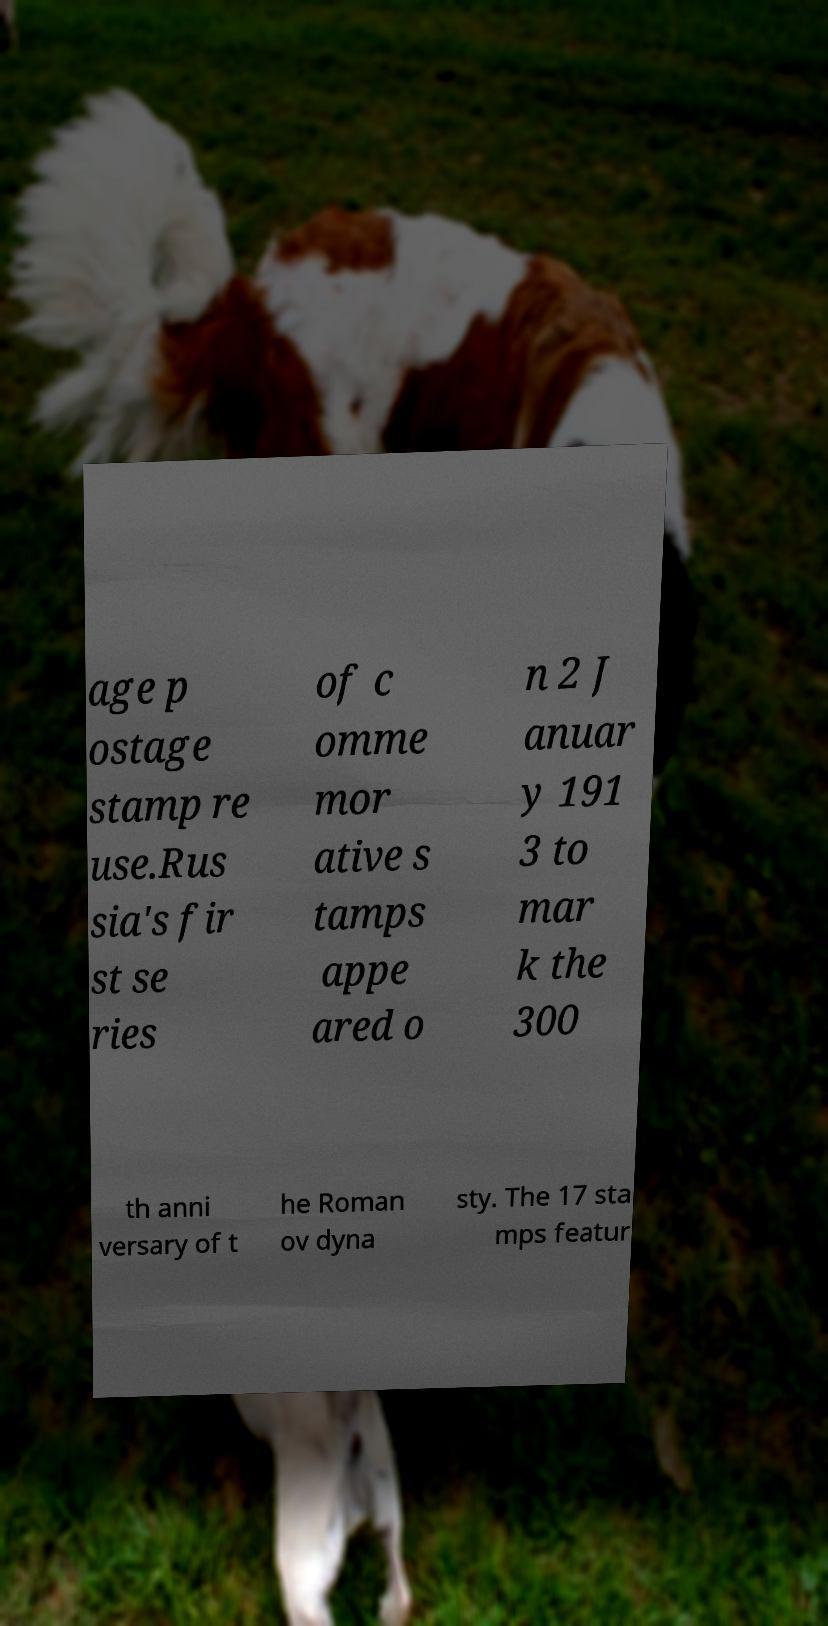Can you accurately transcribe the text from the provided image for me? age p ostage stamp re use.Rus sia's fir st se ries of c omme mor ative s tamps appe ared o n 2 J anuar y 191 3 to mar k the 300 th anni versary of t he Roman ov dyna sty. The 17 sta mps featur 